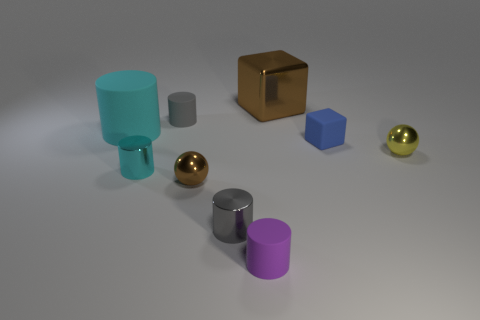Subtract all big cyan matte cylinders. How many cylinders are left? 4 Subtract all gray balls. How many cyan cylinders are left? 2 Subtract all cyan cylinders. How many cylinders are left? 3 Add 1 tiny yellow shiny objects. How many objects exist? 10 Subtract all brown cylinders. Subtract all brown cubes. How many cylinders are left? 5 Subtract all balls. How many objects are left? 7 Subtract all large cyan things. Subtract all brown objects. How many objects are left? 6 Add 3 small purple cylinders. How many small purple cylinders are left? 4 Add 7 gray rubber cylinders. How many gray rubber cylinders exist? 8 Subtract 0 purple spheres. How many objects are left? 9 